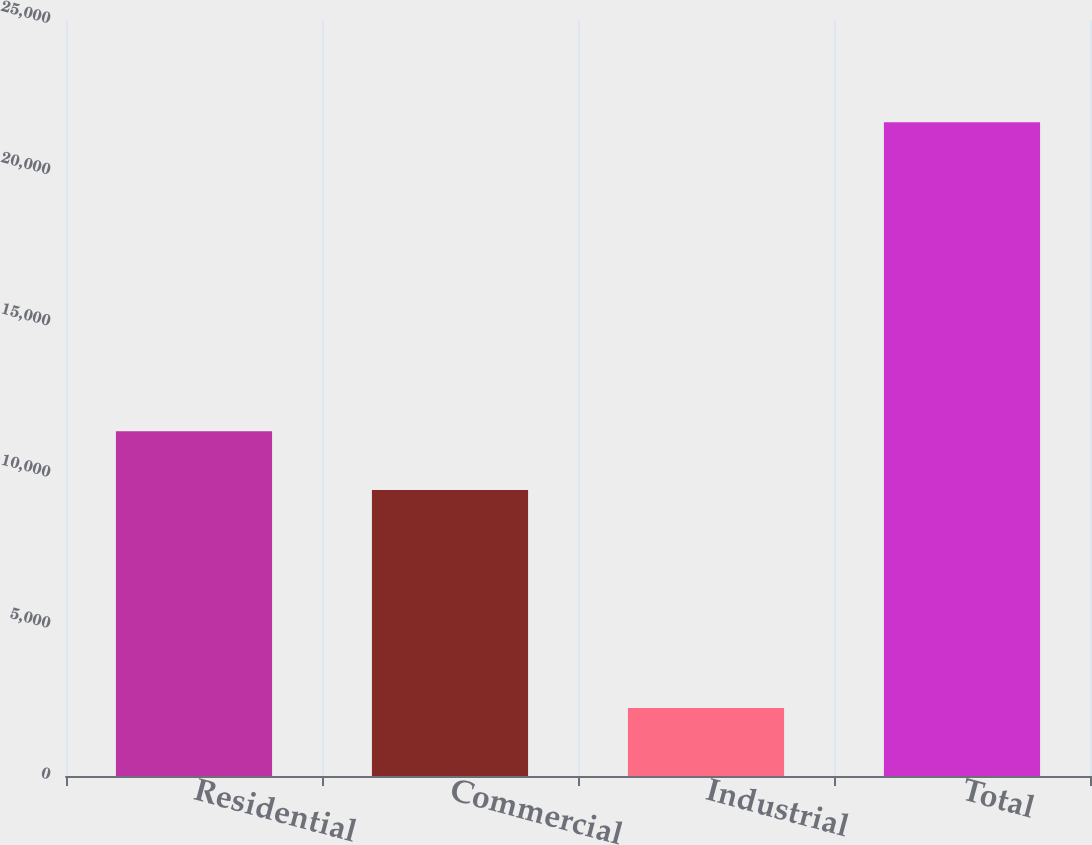Convert chart to OTSL. <chart><loc_0><loc_0><loc_500><loc_500><bar_chart><fcel>Residential<fcel>Commercial<fcel>Industrial<fcel>Total<nl><fcel>11397.8<fcel>9461<fcel>2249<fcel>21617<nl></chart> 